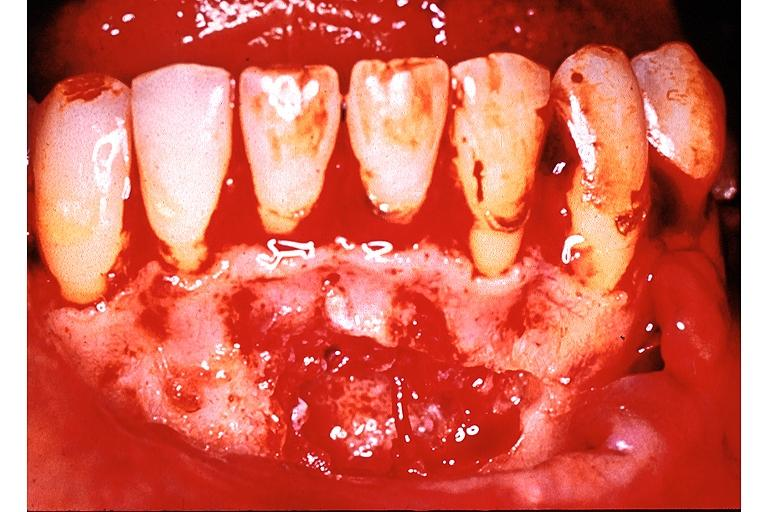does this image show traumatic bone cyst simple bone cyst?
Answer the question using a single word or phrase. Yes 